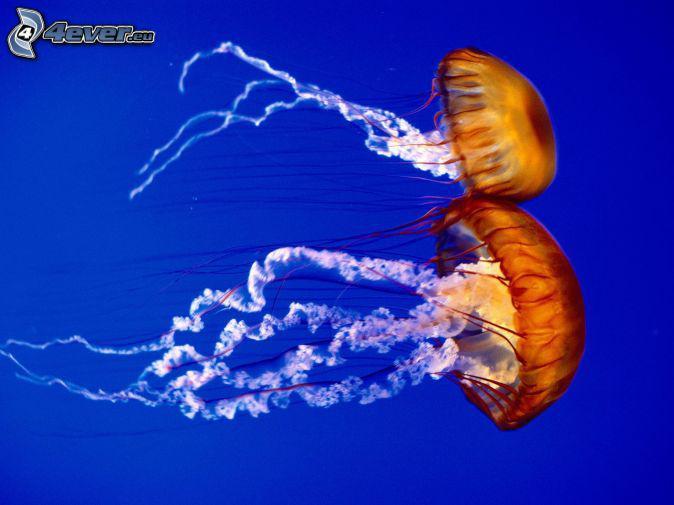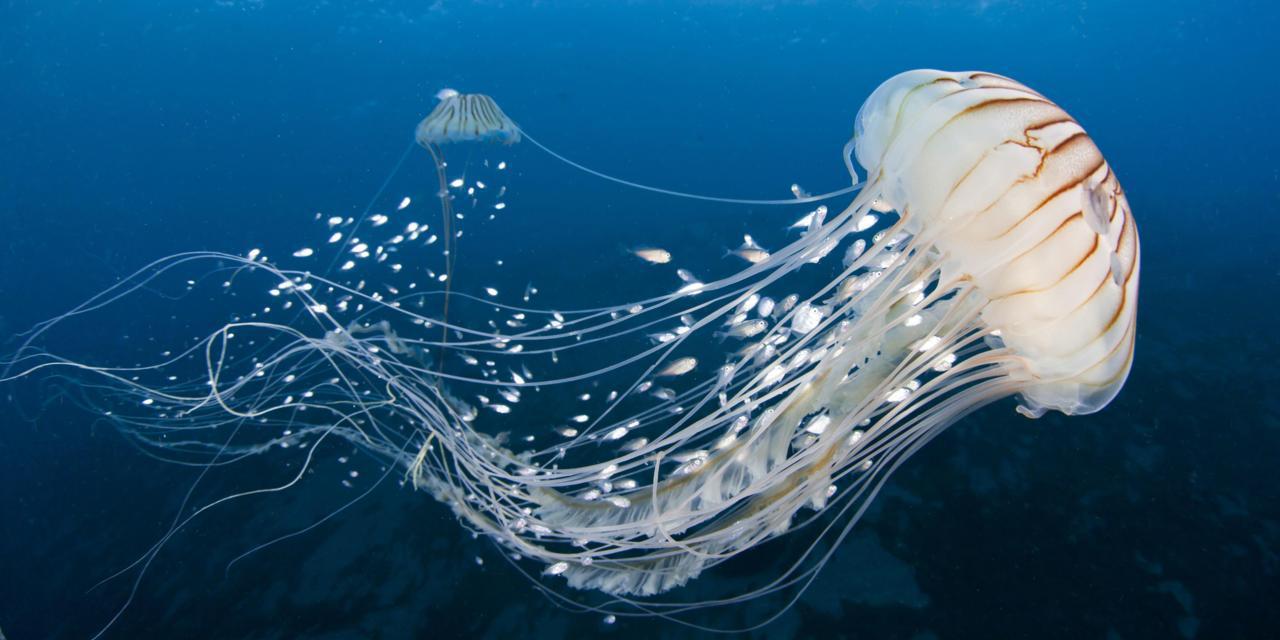The first image is the image on the left, the second image is the image on the right. Assess this claim about the two images: "An image shows at least a dozen vivid orange-red jellyfish.". Correct or not? Answer yes or no. No. 